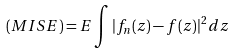Convert formula to latex. <formula><loc_0><loc_0><loc_500><loc_500>( M I S E ) = E \int | f _ { n } ( z ) - f ( z ) | ^ { 2 } d z</formula> 